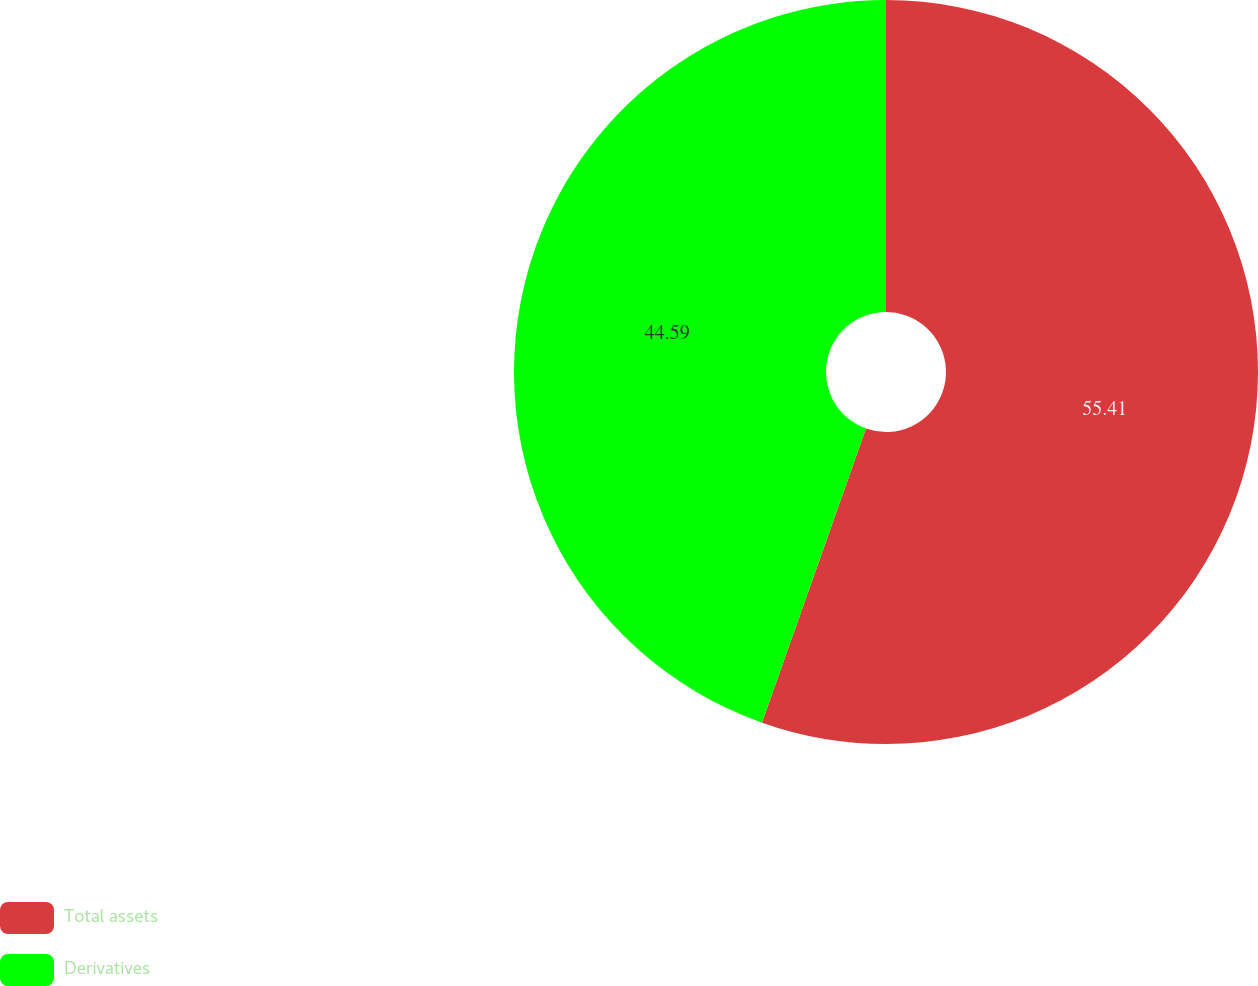Convert chart. <chart><loc_0><loc_0><loc_500><loc_500><pie_chart><fcel>Total assets<fcel>Derivatives<nl><fcel>55.41%<fcel>44.59%<nl></chart> 